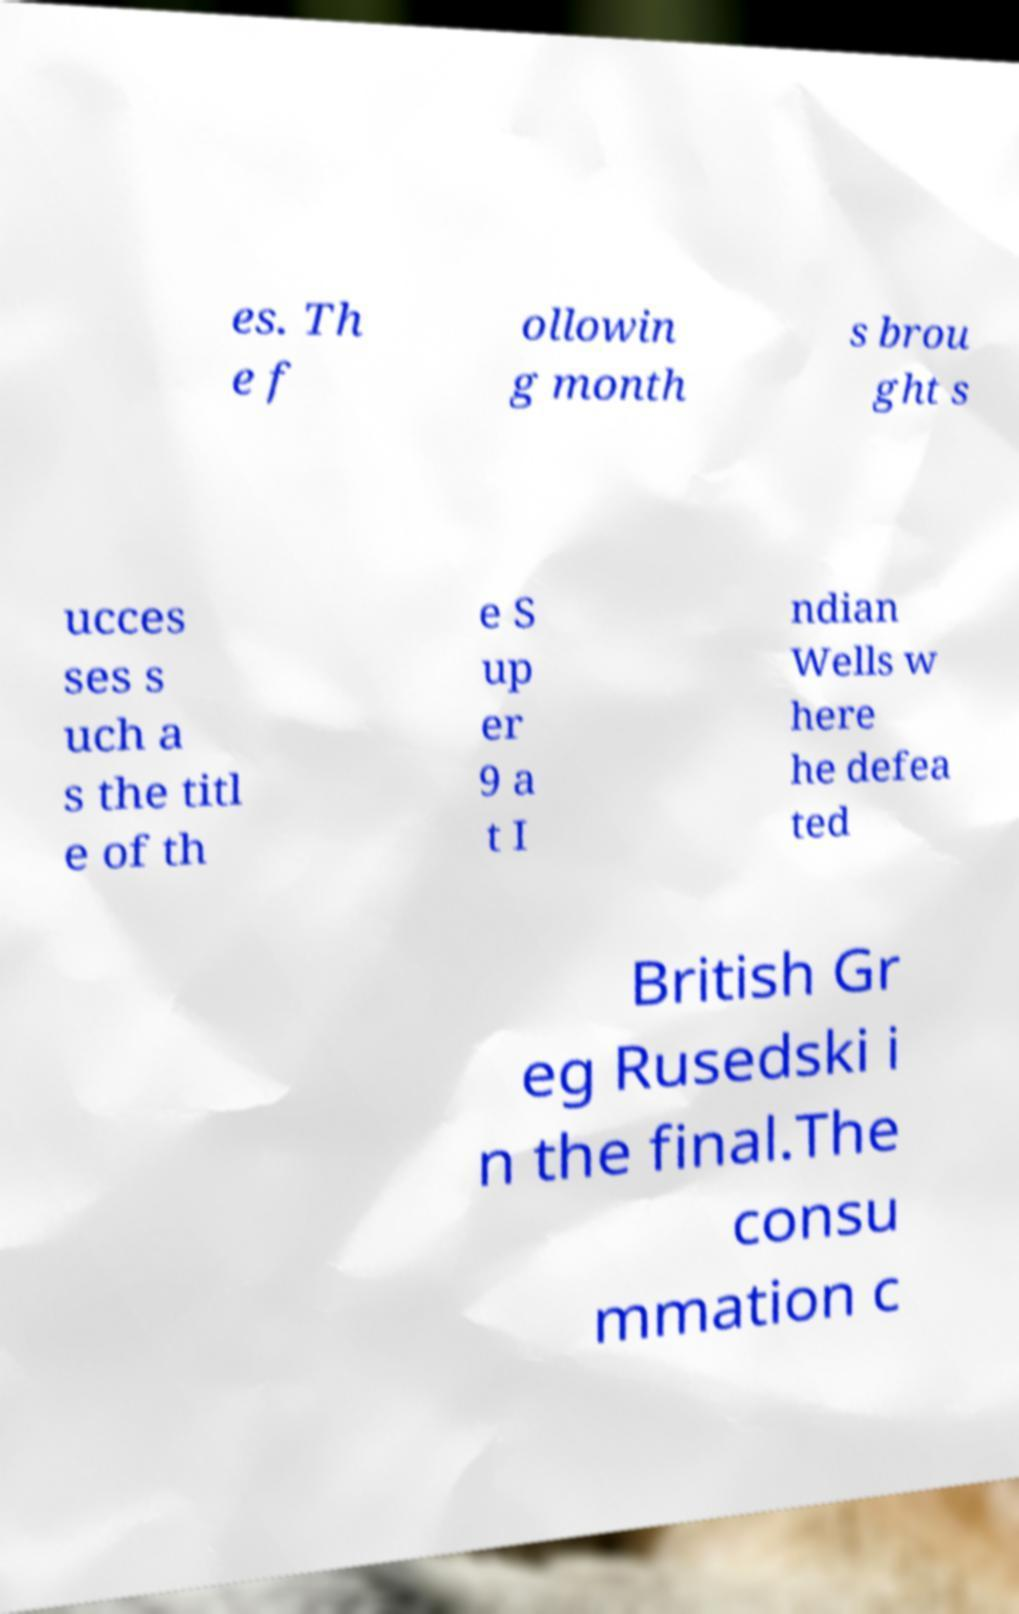Could you extract and type out the text from this image? es. Th e f ollowin g month s brou ght s ucces ses s uch a s the titl e of th e S up er 9 a t I ndian Wells w here he defea ted British Gr eg Rusedski i n the final.The consu mmation c 